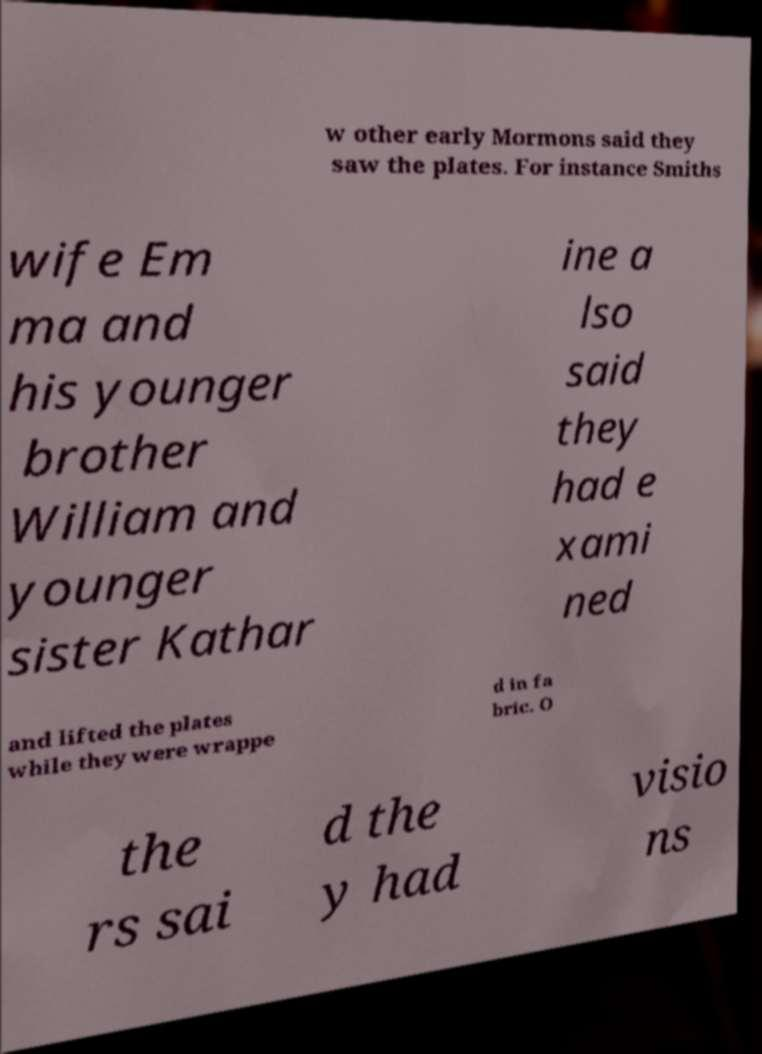Can you accurately transcribe the text from the provided image for me? w other early Mormons said they saw the plates. For instance Smiths wife Em ma and his younger brother William and younger sister Kathar ine a lso said they had e xami ned and lifted the plates while they were wrappe d in fa bric. O the rs sai d the y had visio ns 